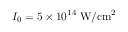Convert formula to latex. <formula><loc_0><loc_0><loc_500><loc_500>I _ { 0 } = 5 \times 1 0 ^ { 1 4 } \, W / c m ^ { 2 }</formula> 